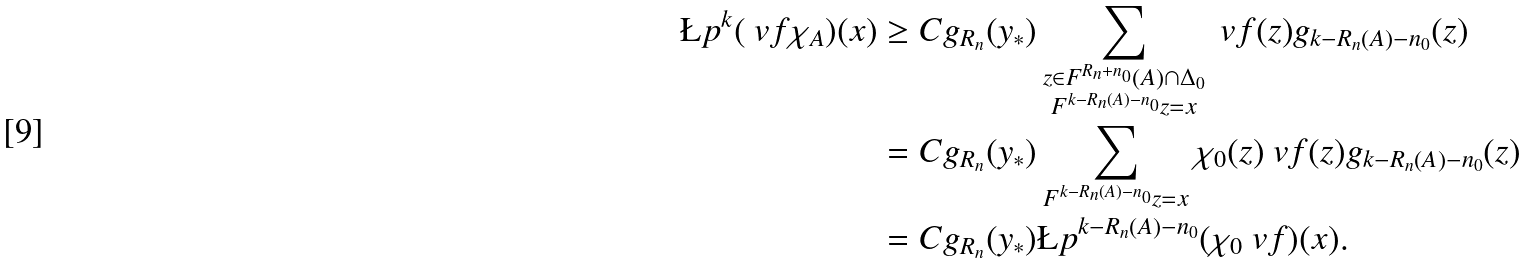Convert formula to latex. <formula><loc_0><loc_0><loc_500><loc_500>\L p ^ { k } ( \ v f \chi _ { A } ) ( x ) & \geq C g _ { R _ { n } } ( y _ { * } ) \sum _ { \substack { z \in F ^ { R _ { n } + n _ { 0 } } ( A ) \cap \Delta _ { 0 } \\ F ^ { k - R _ { n } ( A ) - n _ { 0 } } z = x } } \ v f ( z ) g _ { k - R _ { n } ( A ) - n _ { 0 } } ( z ) \\ & = C g _ { R _ { n } } ( y _ { * } ) \sum _ { F ^ { k - R _ { n } ( A ) - n _ { 0 } } z = x } \chi _ { 0 } ( z ) \ v f ( z ) g _ { k - R _ { n } ( A ) - n _ { 0 } } ( z ) \\ & = C g _ { R _ { n } } ( y _ { * } ) \L p ^ { k - R _ { n } ( A ) - n _ { 0 } } ( \chi _ { 0 } \ v f ) ( x ) .</formula> 